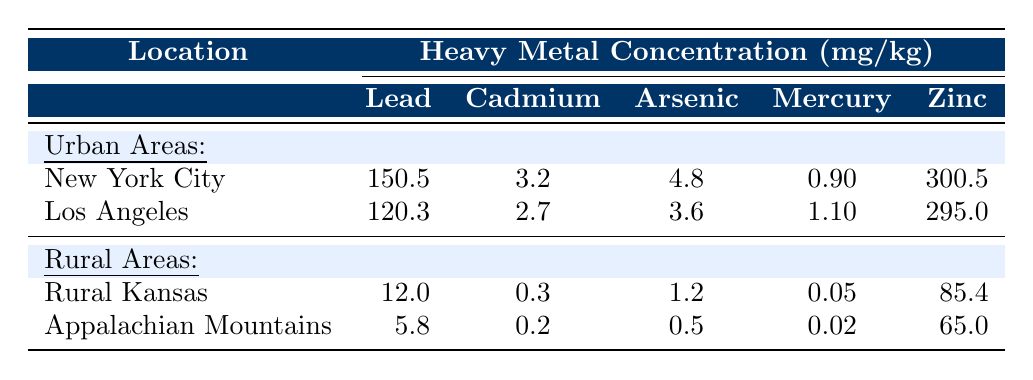What is the concentration of Lead in New York City? The table shows that the concentration of Lead in New York City is listed under the Urban Areas section; specifically, it is 150.5 mg/kg.
Answer: 150.5 mg/kg Which city has a higher concentration of Cadmium, New York City or Los Angeles? By comparing the values in the table, New York City has a Cadmium concentration of 3.2 mg/kg, while Los Angeles has 2.7 mg/kg. Therefore, New York City has a higher concentration.
Answer: New York City What is the difference in concentration of Arsenic between Rural Kansas and Appalachian Mountains? The table provides the concentration of Arsenic as 1.2 mg/kg for Rural Kansas and 0.5 mg/kg for Appalachian Mountains. The difference is calculated as 1.2 - 0.5 = 0.7 mg/kg.
Answer: 0.7 mg/kg What is the average concentration of Zinc in Urban areas? The concentrations for Zinc in Urban areas are 300.5 mg/kg (New York City) and 295.0 mg/kg (Los Angeles). The average is calculated as (300.5 + 295.0) / 2 = 297.75 mg/kg.
Answer: 297.8 mg/kg Is the concentration of Mercury in any Rural area higher than in Urban areas? The-table shows that the highest Mercury concentration in Urban areas is 1.1 mg/kg (Los Angeles), while the highest in Rural areas is 0.05 mg/kg (Rural Kansas) and 0.02 mg/kg (Appalachian Mountains). Therefore, the statement is false, as no Rural area exceeds the Urban concentration.
Answer: No What is the total concentration of Lead across all Urban areas in 2021? By summing the Lead concentrations in the Urban areas: New York City (150.5 mg/kg) + Los Angeles (120.3 mg/kg) = 270.8 mg/kg.
Answer: 270.8 mg/kg Which heavy metal concentration is the lowest in Appalachian Mountains? The table indicates that the concentrations of heavy metals in Appalachian Mountains are: Lead (5.8 mg/kg), Cadmium (0.2 mg/kg), Arsenic (0.5 mg/kg), Mercury (0.02 mg/kg), and Zinc (65.0 mg/kg). The lowest concentration is Mercury at 0.02 mg/kg.
Answer: Mercury How does the concentration of Zinc in Urban areas compare to Rural areas? For Urban areas, the concentrations for Zinc are 300.5 mg/kg (New York City) and 295.0 mg/kg (Los Angeles), giving an average of 297.75 mg/kg. For Rural areas, the concentrations are 85.4 mg/kg (Rural Kansas) and 65.0 mg/kg (Appalachian Mountains), giving an average of 75.2 mg/kg. Comparing the averages, Urban areas have significantly higher Zinc concentrations.
Answer: Urban areas have higher Zinc concentrations What is the total concentration of all heavy metals in Rural Kansas? The concentrations for Rural Kansas are Lead (12.0 mg/kg), Cadmium (0.3 mg/kg), Arsenic (1.2 mg/kg), Mercury (0.05 mg/kg), and Zinc (85.4 mg/kg). The total is calculated as 12.0 + 0.3 + 1.2 + 0.05 + 85.4 = 98.95 mg/kg.
Answer: 98.95 mg/kg 